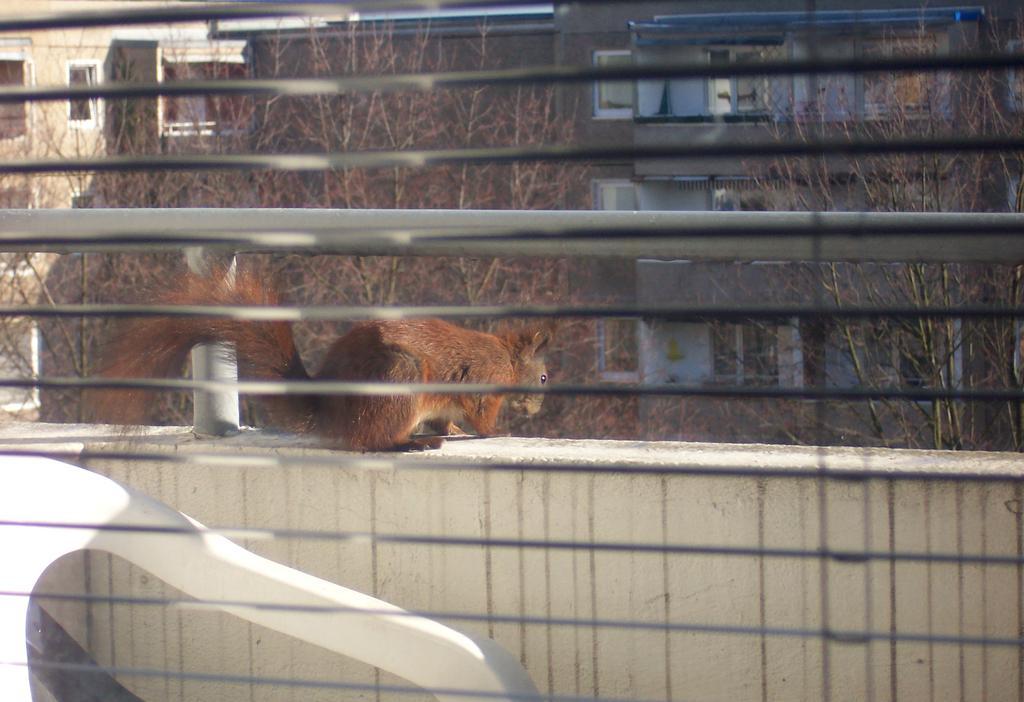Can you describe this image briefly? In this image we can see a squirrel on the wall. In the background we can see group of trees ,buildings and a iron railing. 